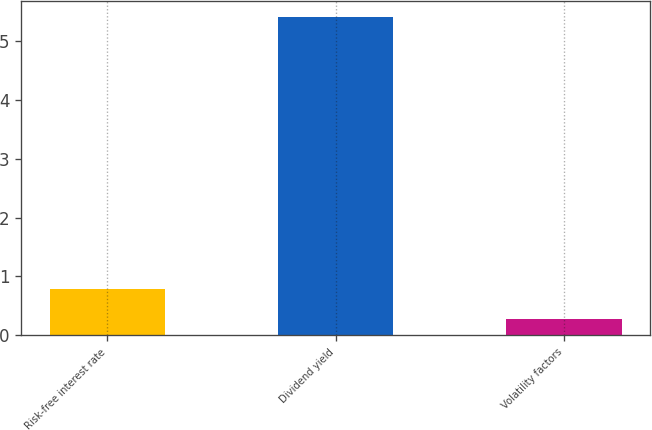Convert chart to OTSL. <chart><loc_0><loc_0><loc_500><loc_500><bar_chart><fcel>Risk-free interest rate<fcel>Dividend yield<fcel>Volatility factors<nl><fcel>0.79<fcel>5.4<fcel>0.28<nl></chart> 